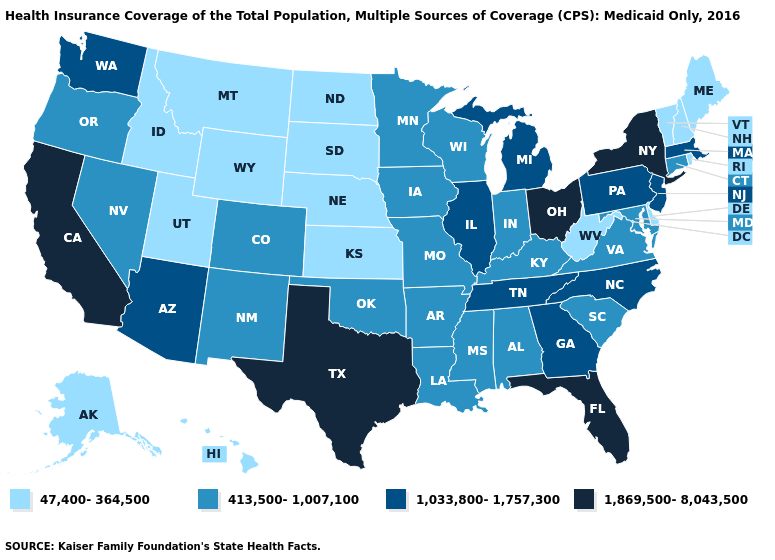Does Ohio have the highest value in the USA?
Keep it brief. Yes. Name the states that have a value in the range 1,033,800-1,757,300?
Short answer required. Arizona, Georgia, Illinois, Massachusetts, Michigan, New Jersey, North Carolina, Pennsylvania, Tennessee, Washington. What is the value of Montana?
Write a very short answer. 47,400-364,500. Is the legend a continuous bar?
Keep it brief. No. Which states have the lowest value in the West?
Answer briefly. Alaska, Hawaii, Idaho, Montana, Utah, Wyoming. Which states have the highest value in the USA?
Be succinct. California, Florida, New York, Ohio, Texas. What is the value of Maine?
Answer briefly. 47,400-364,500. What is the value of South Carolina?
Give a very brief answer. 413,500-1,007,100. Name the states that have a value in the range 1,869,500-8,043,500?
Concise answer only. California, Florida, New York, Ohio, Texas. Does Michigan have the highest value in the USA?
Write a very short answer. No. What is the lowest value in the West?
Be succinct. 47,400-364,500. Does the first symbol in the legend represent the smallest category?
Write a very short answer. Yes. Name the states that have a value in the range 413,500-1,007,100?
Be succinct. Alabama, Arkansas, Colorado, Connecticut, Indiana, Iowa, Kentucky, Louisiana, Maryland, Minnesota, Mississippi, Missouri, Nevada, New Mexico, Oklahoma, Oregon, South Carolina, Virginia, Wisconsin. What is the value of Massachusetts?
Be succinct. 1,033,800-1,757,300. 